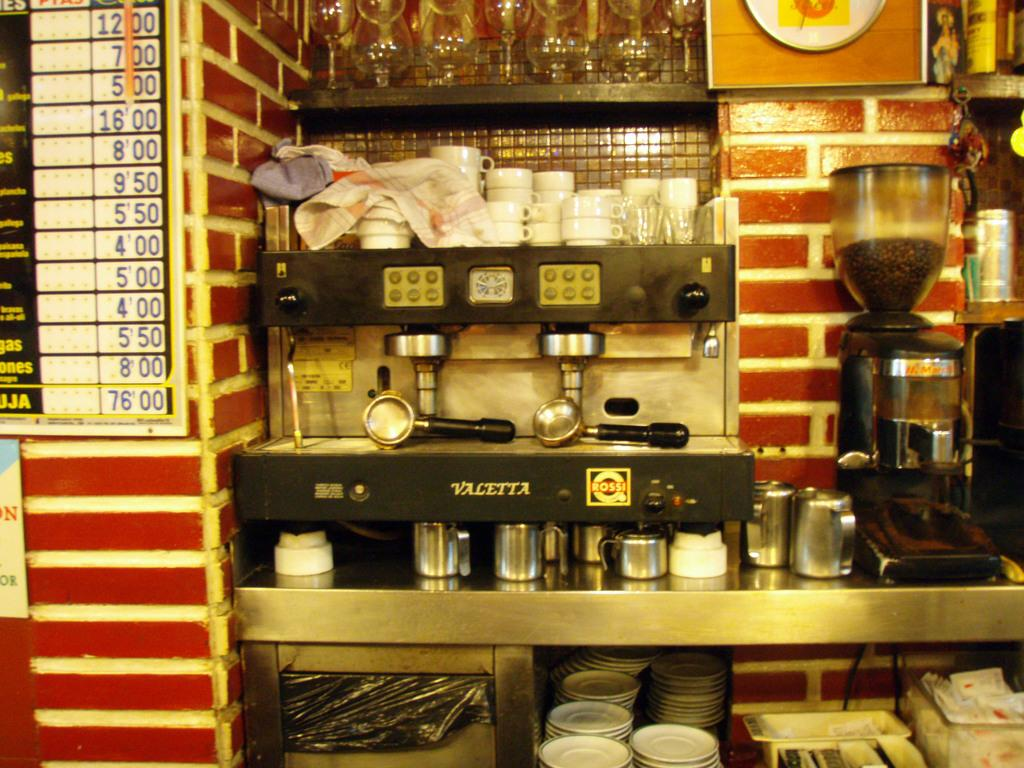Provide a one-sentence caption for the provided image. An coffee shop with a Valetta espresso machine. 